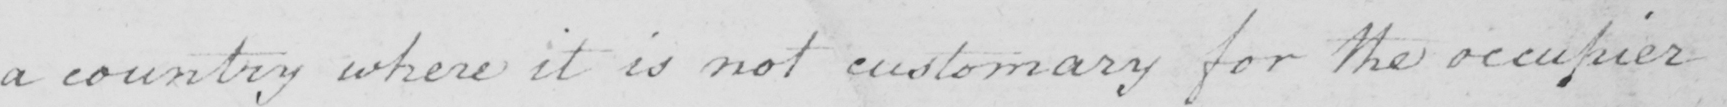Please transcribe the handwritten text in this image. a country where it is not customary for the occupier 